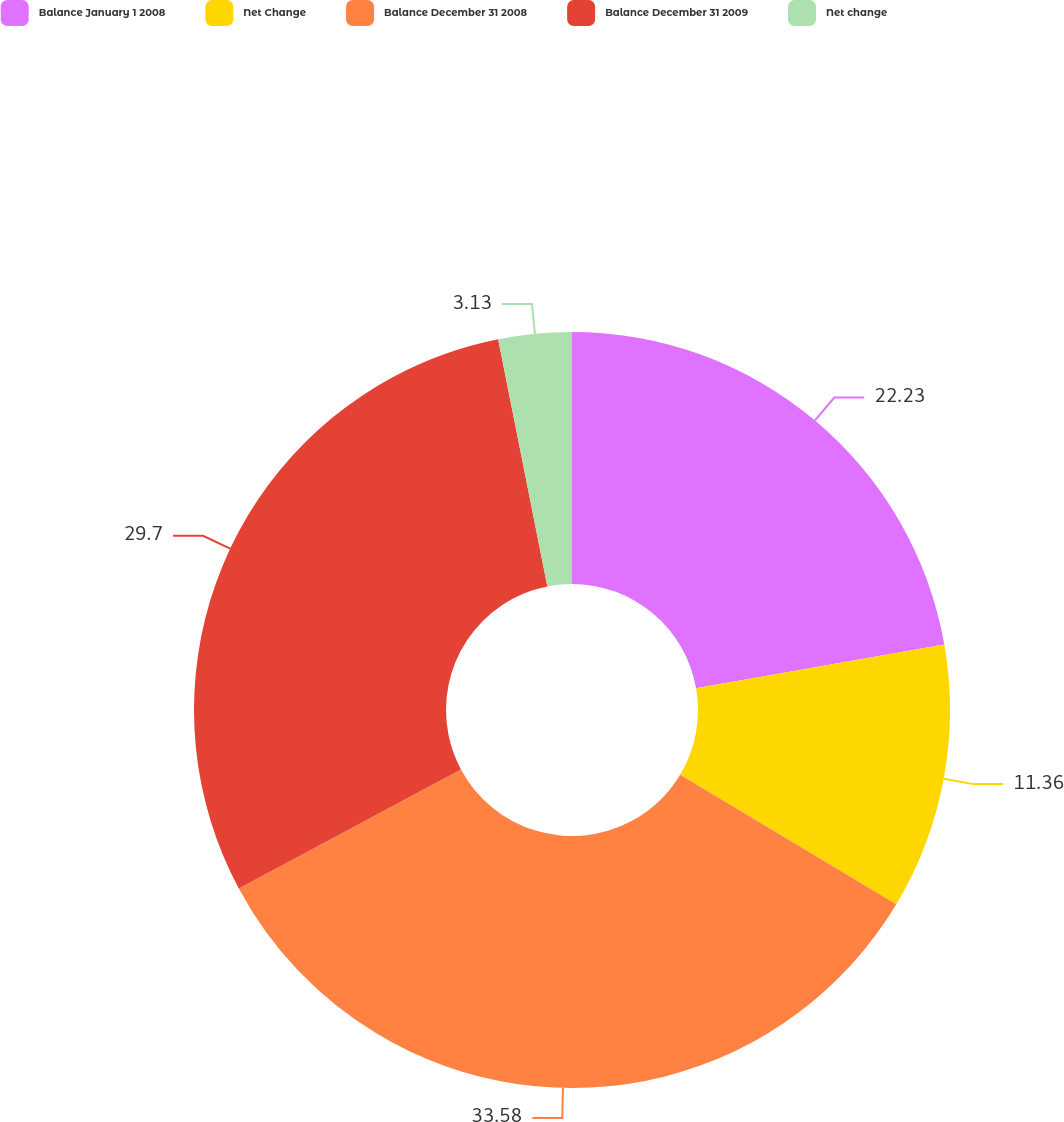Convert chart. <chart><loc_0><loc_0><loc_500><loc_500><pie_chart><fcel>Balance January 1 2008<fcel>Net Change<fcel>Balance December 31 2008<fcel>Balance December 31 2009<fcel>Net change<nl><fcel>22.23%<fcel>11.36%<fcel>33.59%<fcel>29.7%<fcel>3.13%<nl></chart> 